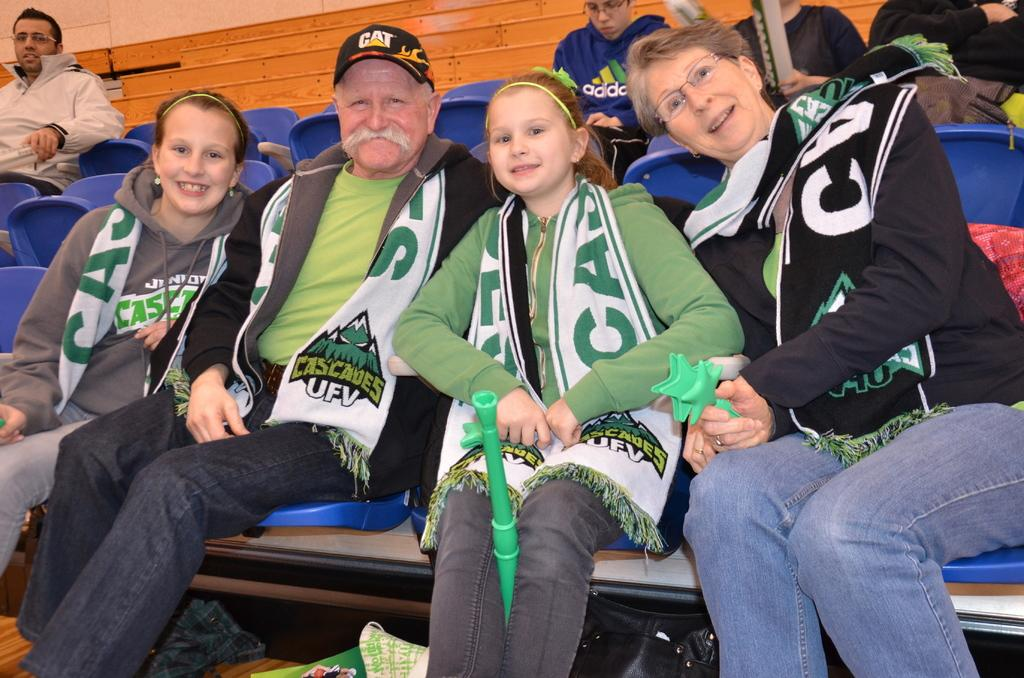What is the person in the image doing? The person is sitting on a chair in the image. What can be seen in the background of the image? There are stairs visible in the background of the image. What team is the person supporting in the battle depicted in the image? There is no battle or team present in the image; it only shows a person sitting on a chair with stairs in the background. 